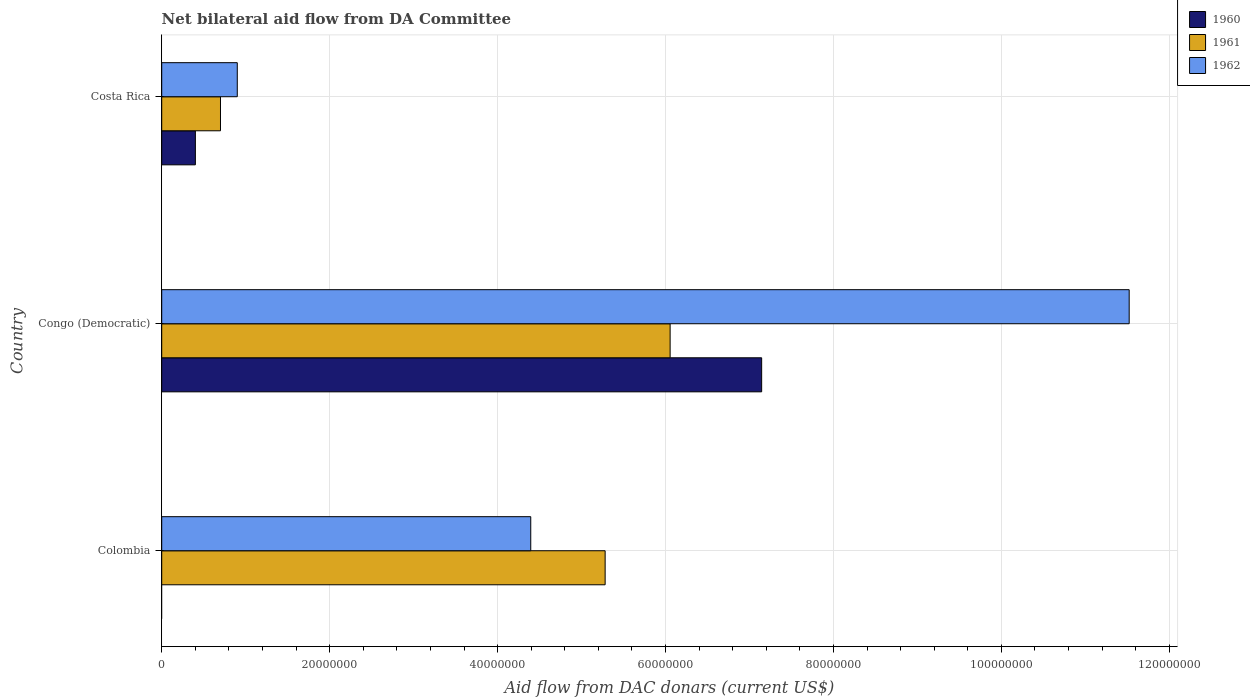Are the number of bars on each tick of the Y-axis equal?
Your answer should be very brief. No. How many bars are there on the 2nd tick from the top?
Your response must be concise. 3. How many bars are there on the 2nd tick from the bottom?
Make the answer very short. 3. In how many cases, is the number of bars for a given country not equal to the number of legend labels?
Ensure brevity in your answer.  1. What is the aid flow in in 1960 in Costa Rica?
Offer a very short reply. 4.01e+06. Across all countries, what is the maximum aid flow in in 1962?
Provide a short and direct response. 1.15e+08. In which country was the aid flow in in 1960 maximum?
Your answer should be very brief. Congo (Democratic). What is the total aid flow in in 1960 in the graph?
Your response must be concise. 7.55e+07. What is the difference between the aid flow in in 1960 in Congo (Democratic) and that in Costa Rica?
Ensure brevity in your answer.  6.74e+07. What is the difference between the aid flow in in 1961 in Costa Rica and the aid flow in in 1962 in Colombia?
Offer a terse response. -3.70e+07. What is the average aid flow in in 1962 per country?
Your answer should be very brief. 5.61e+07. What is the difference between the aid flow in in 1962 and aid flow in in 1961 in Colombia?
Ensure brevity in your answer.  -8.86e+06. What is the ratio of the aid flow in in 1961 in Congo (Democratic) to that in Costa Rica?
Keep it short and to the point. 8.65. Is the aid flow in in 1961 in Colombia less than that in Congo (Democratic)?
Make the answer very short. Yes. What is the difference between the highest and the second highest aid flow in in 1962?
Give a very brief answer. 7.13e+07. What is the difference between the highest and the lowest aid flow in in 1961?
Ensure brevity in your answer.  5.36e+07. Is the sum of the aid flow in in 1962 in Colombia and Costa Rica greater than the maximum aid flow in in 1960 across all countries?
Keep it short and to the point. No. How many bars are there?
Give a very brief answer. 8. How many countries are there in the graph?
Make the answer very short. 3. What is the difference between two consecutive major ticks on the X-axis?
Your response must be concise. 2.00e+07. Does the graph contain any zero values?
Make the answer very short. Yes. Does the graph contain grids?
Provide a short and direct response. Yes. Where does the legend appear in the graph?
Offer a terse response. Top right. What is the title of the graph?
Provide a succinct answer. Net bilateral aid flow from DA Committee. What is the label or title of the X-axis?
Offer a very short reply. Aid flow from DAC donars (current US$). What is the label or title of the Y-axis?
Offer a terse response. Country. What is the Aid flow from DAC donars (current US$) of 1960 in Colombia?
Offer a terse response. 0. What is the Aid flow from DAC donars (current US$) in 1961 in Colombia?
Give a very brief answer. 5.28e+07. What is the Aid flow from DAC donars (current US$) of 1962 in Colombia?
Your answer should be very brief. 4.40e+07. What is the Aid flow from DAC donars (current US$) of 1960 in Congo (Democratic)?
Give a very brief answer. 7.14e+07. What is the Aid flow from DAC donars (current US$) of 1961 in Congo (Democratic)?
Keep it short and to the point. 6.06e+07. What is the Aid flow from DAC donars (current US$) of 1962 in Congo (Democratic)?
Your answer should be very brief. 1.15e+08. What is the Aid flow from DAC donars (current US$) of 1960 in Costa Rica?
Offer a terse response. 4.01e+06. What is the Aid flow from DAC donars (current US$) of 1961 in Costa Rica?
Give a very brief answer. 7.00e+06. What is the Aid flow from DAC donars (current US$) of 1962 in Costa Rica?
Your answer should be compact. 9.00e+06. Across all countries, what is the maximum Aid flow from DAC donars (current US$) of 1960?
Ensure brevity in your answer.  7.14e+07. Across all countries, what is the maximum Aid flow from DAC donars (current US$) in 1961?
Keep it short and to the point. 6.06e+07. Across all countries, what is the maximum Aid flow from DAC donars (current US$) of 1962?
Make the answer very short. 1.15e+08. Across all countries, what is the minimum Aid flow from DAC donars (current US$) of 1961?
Your response must be concise. 7.00e+06. Across all countries, what is the minimum Aid flow from DAC donars (current US$) of 1962?
Your answer should be compact. 9.00e+06. What is the total Aid flow from DAC donars (current US$) in 1960 in the graph?
Your answer should be very brief. 7.55e+07. What is the total Aid flow from DAC donars (current US$) in 1961 in the graph?
Offer a terse response. 1.20e+08. What is the total Aid flow from DAC donars (current US$) in 1962 in the graph?
Your answer should be very brief. 1.68e+08. What is the difference between the Aid flow from DAC donars (current US$) of 1961 in Colombia and that in Congo (Democratic)?
Provide a succinct answer. -7.74e+06. What is the difference between the Aid flow from DAC donars (current US$) of 1962 in Colombia and that in Congo (Democratic)?
Make the answer very short. -7.13e+07. What is the difference between the Aid flow from DAC donars (current US$) in 1961 in Colombia and that in Costa Rica?
Provide a succinct answer. 4.58e+07. What is the difference between the Aid flow from DAC donars (current US$) in 1962 in Colombia and that in Costa Rica?
Provide a short and direct response. 3.50e+07. What is the difference between the Aid flow from DAC donars (current US$) of 1960 in Congo (Democratic) and that in Costa Rica?
Keep it short and to the point. 6.74e+07. What is the difference between the Aid flow from DAC donars (current US$) of 1961 in Congo (Democratic) and that in Costa Rica?
Make the answer very short. 5.36e+07. What is the difference between the Aid flow from DAC donars (current US$) in 1962 in Congo (Democratic) and that in Costa Rica?
Offer a terse response. 1.06e+08. What is the difference between the Aid flow from DAC donars (current US$) of 1961 in Colombia and the Aid flow from DAC donars (current US$) of 1962 in Congo (Democratic)?
Ensure brevity in your answer.  -6.24e+07. What is the difference between the Aid flow from DAC donars (current US$) of 1961 in Colombia and the Aid flow from DAC donars (current US$) of 1962 in Costa Rica?
Ensure brevity in your answer.  4.38e+07. What is the difference between the Aid flow from DAC donars (current US$) in 1960 in Congo (Democratic) and the Aid flow from DAC donars (current US$) in 1961 in Costa Rica?
Keep it short and to the point. 6.44e+07. What is the difference between the Aid flow from DAC donars (current US$) of 1960 in Congo (Democratic) and the Aid flow from DAC donars (current US$) of 1962 in Costa Rica?
Your answer should be compact. 6.24e+07. What is the difference between the Aid flow from DAC donars (current US$) of 1961 in Congo (Democratic) and the Aid flow from DAC donars (current US$) of 1962 in Costa Rica?
Make the answer very short. 5.16e+07. What is the average Aid flow from DAC donars (current US$) of 1960 per country?
Offer a terse response. 2.52e+07. What is the average Aid flow from DAC donars (current US$) of 1961 per country?
Provide a succinct answer. 4.01e+07. What is the average Aid flow from DAC donars (current US$) in 1962 per country?
Ensure brevity in your answer.  5.61e+07. What is the difference between the Aid flow from DAC donars (current US$) in 1961 and Aid flow from DAC donars (current US$) in 1962 in Colombia?
Offer a very short reply. 8.86e+06. What is the difference between the Aid flow from DAC donars (current US$) of 1960 and Aid flow from DAC donars (current US$) of 1961 in Congo (Democratic)?
Give a very brief answer. 1.09e+07. What is the difference between the Aid flow from DAC donars (current US$) in 1960 and Aid flow from DAC donars (current US$) in 1962 in Congo (Democratic)?
Give a very brief answer. -4.38e+07. What is the difference between the Aid flow from DAC donars (current US$) in 1961 and Aid flow from DAC donars (current US$) in 1962 in Congo (Democratic)?
Provide a succinct answer. -5.47e+07. What is the difference between the Aid flow from DAC donars (current US$) of 1960 and Aid flow from DAC donars (current US$) of 1961 in Costa Rica?
Your response must be concise. -2.99e+06. What is the difference between the Aid flow from DAC donars (current US$) in 1960 and Aid flow from DAC donars (current US$) in 1962 in Costa Rica?
Your answer should be compact. -4.99e+06. What is the ratio of the Aid flow from DAC donars (current US$) in 1961 in Colombia to that in Congo (Democratic)?
Keep it short and to the point. 0.87. What is the ratio of the Aid flow from DAC donars (current US$) of 1962 in Colombia to that in Congo (Democratic)?
Provide a short and direct response. 0.38. What is the ratio of the Aid flow from DAC donars (current US$) of 1961 in Colombia to that in Costa Rica?
Your answer should be very brief. 7.54. What is the ratio of the Aid flow from DAC donars (current US$) of 1962 in Colombia to that in Costa Rica?
Provide a succinct answer. 4.88. What is the ratio of the Aid flow from DAC donars (current US$) in 1960 in Congo (Democratic) to that in Costa Rica?
Provide a succinct answer. 17.82. What is the ratio of the Aid flow from DAC donars (current US$) of 1961 in Congo (Democratic) to that in Costa Rica?
Offer a terse response. 8.65. What is the ratio of the Aid flow from DAC donars (current US$) in 1962 in Congo (Democratic) to that in Costa Rica?
Make the answer very short. 12.8. What is the difference between the highest and the second highest Aid flow from DAC donars (current US$) in 1961?
Give a very brief answer. 7.74e+06. What is the difference between the highest and the second highest Aid flow from DAC donars (current US$) of 1962?
Make the answer very short. 7.13e+07. What is the difference between the highest and the lowest Aid flow from DAC donars (current US$) in 1960?
Make the answer very short. 7.14e+07. What is the difference between the highest and the lowest Aid flow from DAC donars (current US$) in 1961?
Your answer should be compact. 5.36e+07. What is the difference between the highest and the lowest Aid flow from DAC donars (current US$) in 1962?
Provide a succinct answer. 1.06e+08. 